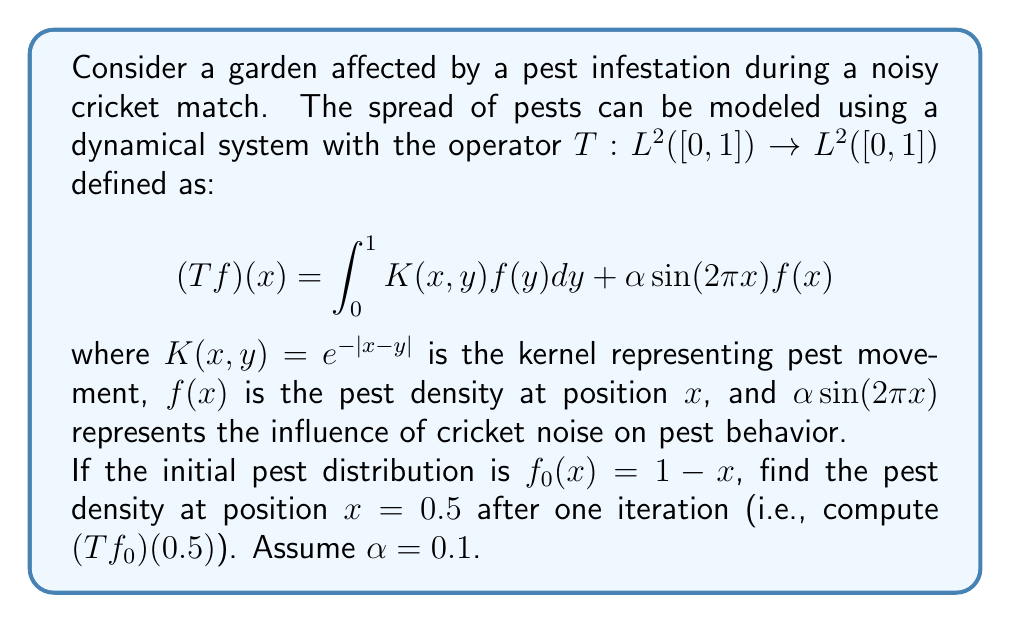Show me your answer to this math problem. Let's approach this step-by-step:

1) We need to calculate $(Tf_0)(0.5)$. This means we need to evaluate:

   $$(Tf_0)(0.5) = \int_0^1 K(0.5,y)f_0(y)dy + \alpha \sin(2\pi \cdot 0.5)f_0(0.5)$$

2) Let's break this down into two parts: the integral and the sinusoidal term.

3) For the integral:
   $$\int_0^1 K(0.5,y)f_0(y)dy = \int_0^1 e^{-|0.5-y|}(1-y)dy$$

4) We can split this integral at y = 0.5:
   $$\int_0^{0.5} e^{-(0.5-y)}(1-y)dy + \int_{0.5}^1 e^{-(y-0.5)}(1-y)dy$$

5) Let's solve these integrals:
   For the first integral, let u = 0.5-y, du = -dy:
   $$\int_{0.5}^0 -e^{-u}(0.5+u)du = [-e^{-u}(0.5+u)]_{0.5}^0 + \int_{0.5}^0 e^{-u}du = 0.5 - 0.25e^{-0.5} - (1-e^{-0.5})$$

   For the second integral, let u = y-0.5, du = dy:
   $$\int_0^{0.5} e^{-u}(0.5-u)du = [e^{-u}(0.5-u)]_0^{0.5} + \int_0^{0.5} e^{-u}du = 0.25e^{-0.5} - (1-e^{-0.5})$$

6) Adding these results:
   $$0.5 - 0.25e^{-0.5} - (1-e^{-0.5}) + 0.25e^{-0.5} - (1-e^{-0.5}) = 0.5 - 2 + 2e^{-0.5} \approx 0.2131$$

7) Now for the sinusoidal term:
   $$\alpha \sin(2\pi \cdot 0.5)f_0(0.5) = 0.1 \cdot \sin(\pi) \cdot (1-0.5) = 0$$

8) Adding the results from steps 6 and 7:
   $$(Tf_0)(0.5) \approx 0.2131 + 0 = 0.2131$$
Answer: 0.2131 